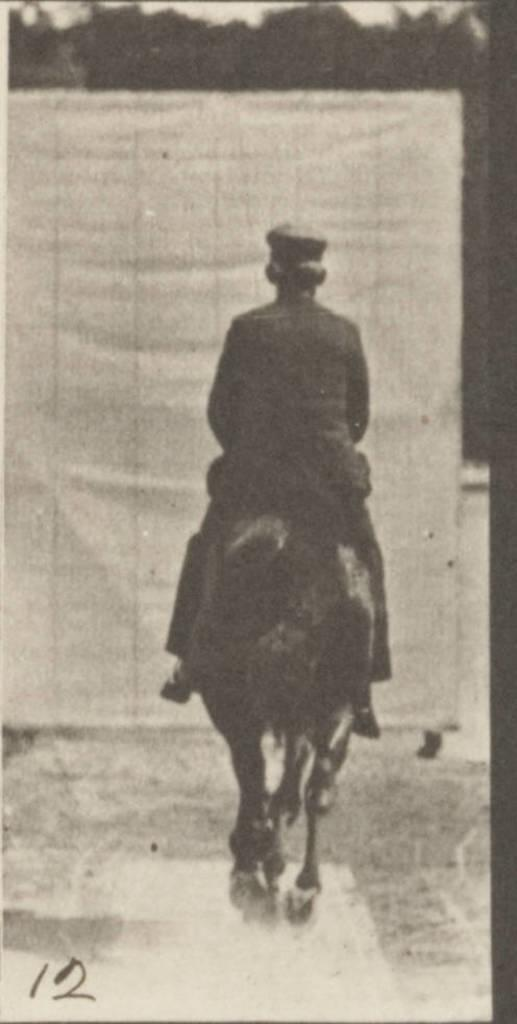What is the main subject of the image? The main subject of the image is a man. What is the man doing in the image? The man is riding a horse in the image. What is the terrain like where the horse and rider are located? The horse and rider are on a mud road. What can be seen in the background of the image? There are trees in the background of the image. What type of cream can be seen being applied to the beast in the image? There is no cream or beast present in the image. What color is the silver horse in the image? There is no silver horse present in the image; the horse is not described as being silver. 